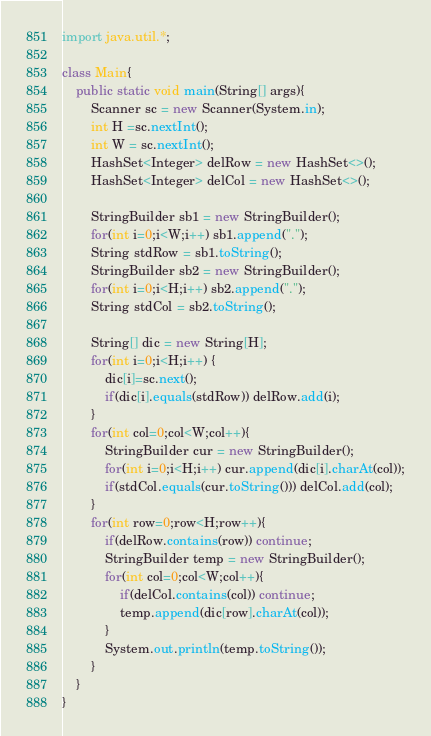<code> <loc_0><loc_0><loc_500><loc_500><_Java_>import java.util.*;

class Main{
    public static void main(String[] args){
        Scanner sc = new Scanner(System.in);
        int H =sc.nextInt();
        int W = sc.nextInt();
        HashSet<Integer> delRow = new HashSet<>();
        HashSet<Integer> delCol = new HashSet<>();

        StringBuilder sb1 = new StringBuilder();
        for(int i=0;i<W;i++) sb1.append(".");
        String stdRow = sb1.toString();
        StringBuilder sb2 = new StringBuilder();
        for(int i=0;i<H;i++) sb2.append(".");
        String stdCol = sb2.toString();

        String[] dic = new String[H];
        for(int i=0;i<H;i++) {
            dic[i]=sc.next();
            if(dic[i].equals(stdRow)) delRow.add(i);
        }
        for(int col=0;col<W;col++){
            StringBuilder cur = new StringBuilder();
            for(int i=0;i<H;i++) cur.append(dic[i].charAt(col));
            if(stdCol.equals(cur.toString())) delCol.add(col);
        }
        for(int row=0;row<H;row++){
            if(delRow.contains(row)) continue;
            StringBuilder temp = new StringBuilder();
            for(int col=0;col<W;col++){
                if(delCol.contains(col)) continue;
                temp.append(dic[row].charAt(col));
            }
            System.out.println(temp.toString());
        }
    }
}
</code> 